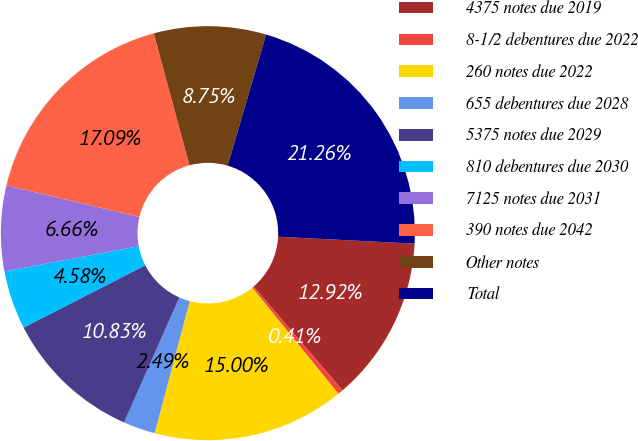Convert chart to OTSL. <chart><loc_0><loc_0><loc_500><loc_500><pie_chart><fcel>4375 notes due 2019<fcel>8-1/2 debentures due 2022<fcel>260 notes due 2022<fcel>655 debentures due 2028<fcel>5375 notes due 2029<fcel>810 debentures due 2030<fcel>7125 notes due 2031<fcel>390 notes due 2042<fcel>Other notes<fcel>Total<nl><fcel>12.92%<fcel>0.41%<fcel>15.0%<fcel>2.49%<fcel>10.83%<fcel>4.58%<fcel>6.66%<fcel>17.09%<fcel>8.75%<fcel>21.26%<nl></chart> 